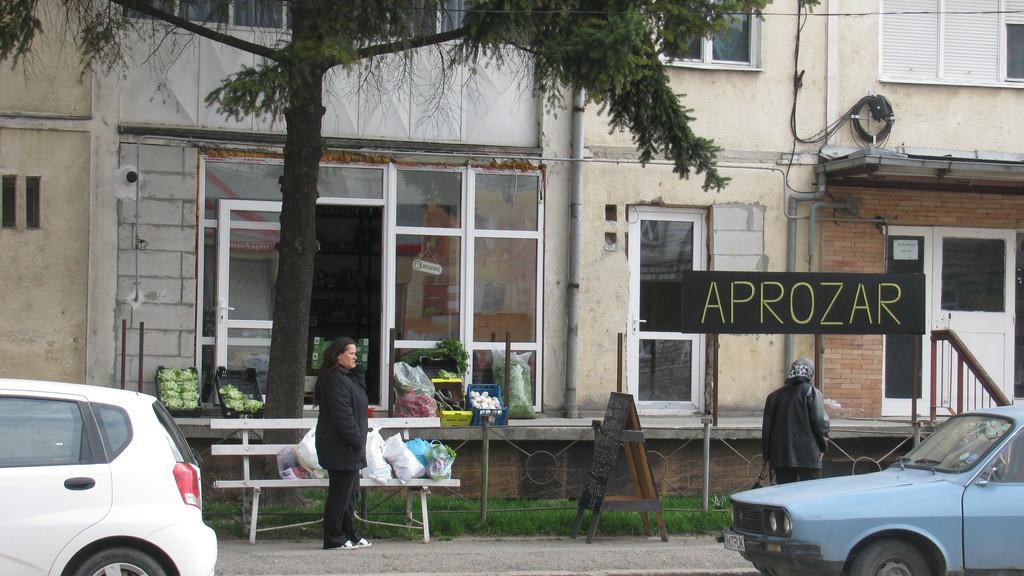Can you describe this image briefly? In this image we can see one building, two persons walking on the road, two cars on the road, one bench, one fence, some vegetables on the surface of the floor, some objects attached to the wall, some wires, one board with text on the road, one board with text attached to the poles, some objects on the bench, some objects in the building, one board with text attached near the door, one tree and grass on the ground. 